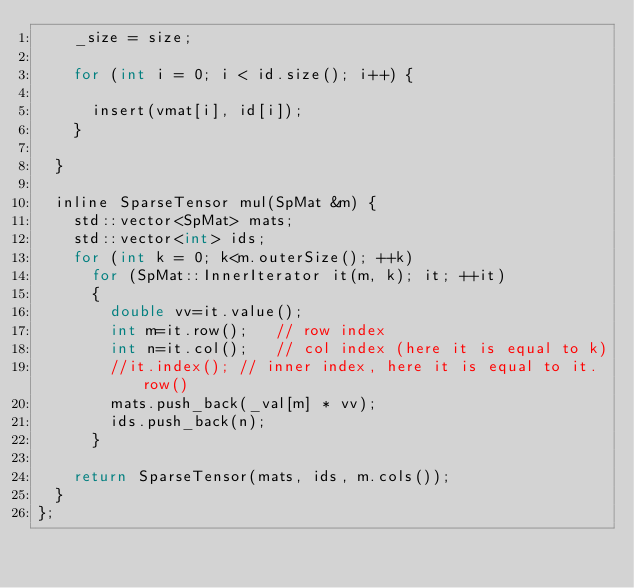<code> <loc_0><loc_0><loc_500><loc_500><_C_>		_size = size;

		for (int i = 0; i < id.size(); i++) {
			
			insert(vmat[i], id[i]);
		}
		
	}

	inline SparseTensor mul(SpMat &m) {
		std::vector<SpMat> mats;
		std::vector<int> ids;
		for (int k = 0; k<m.outerSize(); ++k)
			for (SpMat::InnerIterator it(m, k); it; ++it)
			{
				double vv=it.value();
				int m=it.row();   // row index
				int n=it.col();   // col index (here it is equal to k)
				//it.index(); // inner index, here it is equal to it.row()
				mats.push_back(_val[m] * vv);
				ids.push_back(n);
			}

		return SparseTensor(mats, ids, m.cols());
	}
};

</code> 